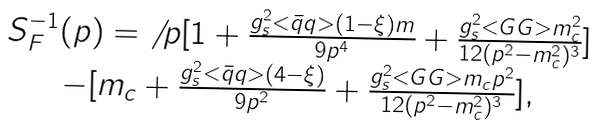<formula> <loc_0><loc_0><loc_500><loc_500>\begin{array} { c l c r } S _ { F } ^ { - 1 } ( p ) = { \not \, p } [ 1 + \frac { g _ { s } ^ { 2 } < \bar { q } q > ( 1 - \xi ) m } { 9 p ^ { 4 } } + \frac { g _ { s } ^ { 2 } < G G > m _ { c } ^ { 2 } } { 1 2 ( p ^ { 2 } - m _ { c } ^ { 2 } ) ^ { 3 } } ] \\ - [ m _ { c } + \frac { g _ { s } ^ { 2 } < \bar { q } q > ( 4 - \xi ) } { 9 p ^ { 2 } } + \frac { g _ { s } ^ { 2 } < G G > m _ { c } p ^ { 2 } } { 1 2 ( p ^ { 2 } - m _ { c } ^ { 2 } ) ^ { 3 } } ] , \end{array}</formula> 